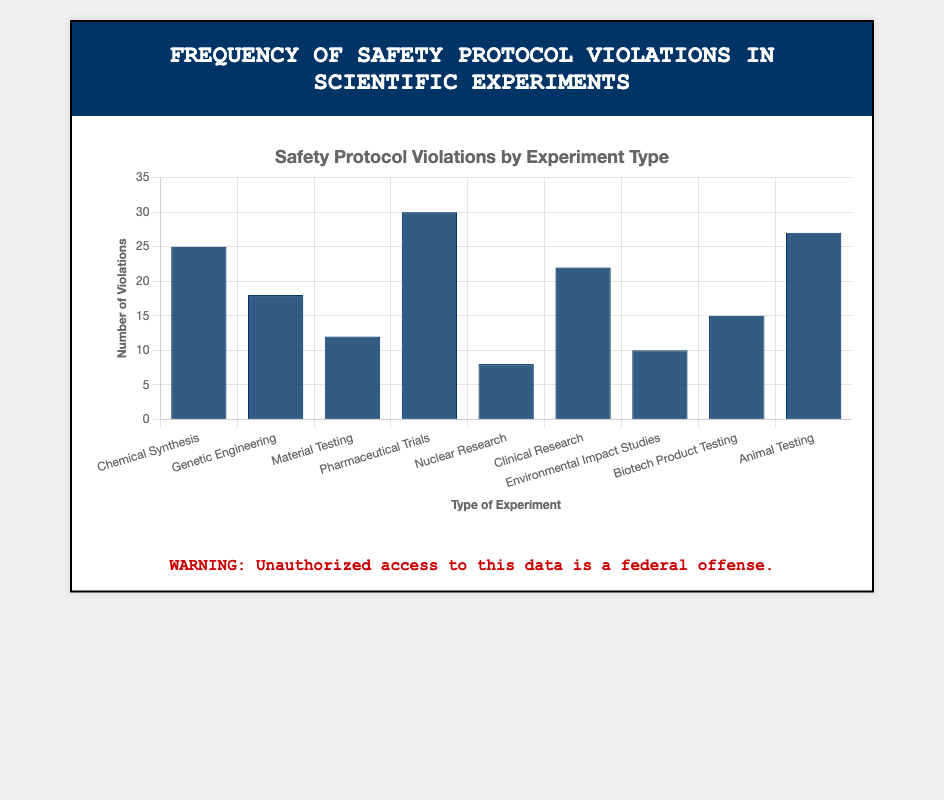Which type of experiment has the highest number of safety protocol violations? By looking at the heights of the bars, the bar corresponding to "Pharmaceutical Trials" is the tallest, indicating the highest number of violations.
Answer: Pharmaceutical Trials What is the total number of safety protocol violations for Animal Testing and Chemical Synthesis combined? Add the safety protocol violations for Animal Testing (27) and Chemical Synthesis (25), which gives 27 + 25 = 52.
Answer: 52 Which type of experiment has fewer safety protocol violations, Genetic Engineering or Biotech Product Testing? By comparing the height of the bars, Genetic Engineering has 18 violations while Biotech Product Testing has 15 violations. Therefore, Biotech Product Testing has fewer violations.
Answer: Biotech Product Testing How many more safety protocol violations does Clinical Research have compared to Nuclear Research? Subtract the number of violations in Nuclear Research (8) from the number of violations in Clinical Research (22), which gives 22 - 8 = 14.
Answer: 14 What is the average number of safety protocol violations across all types of experiments? There are 9 types of experiments. Sum all violations (25 + 18 + 12 + 30 + 8 + 22 + 10 + 15 + 27) which equals 167. Then divide by 9, the average is 167 / 9 ≈ 18.56.
Answer: 18.56 Is the number of safety protocol violations for Environmental Impact Studies closer to the violation count of Genetic Engineering or Material Testing? Environmental Impact Studies have 10 violations, Genetic Engineering has 18, and Material Testing has 12. The difference between Environmental Impact Studies and Genetic Engineering is 18 - 10 = 8, whereas for Material Testing it is 12 - 10 = 2. Therefore, it is closer to Material Testing.
Answer: Material Testing Which type of experiment has the second highest number of safety protocol violations? After the highest, which is Pharmaceutical Trials (30), the next tallest bar corresponds to Animal Testing (27), making it the second highest.
Answer: Animal Testing Do Chemical Synthesis and Clinical Research together have more violations than Pharmaceutical Trials alone? Adding the violations of Chemical Synthesis (25) and Clinical Research (22) gives 25 + 22 = 47, which is more than Pharmaceutical Trials alone (30).
Answer: Yes How many types of experiments have fewer than 15 safety protocol violations? Counting the bars with heights less than 15: Material Testing (12), Nuclear Research (8), Environmental Impact Studies (10), and Biotech Product Testing (15) meet this criterion. There are 4 such types.
Answer: 4 